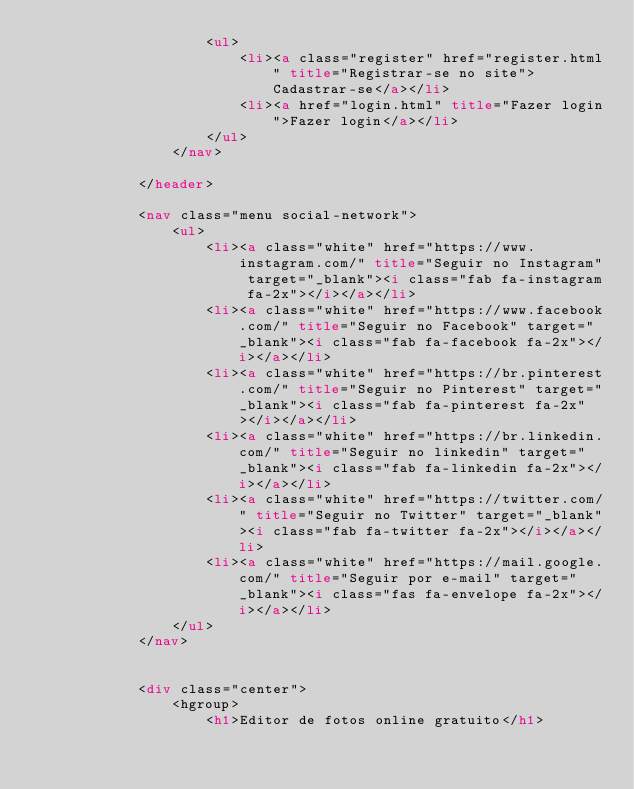<code> <loc_0><loc_0><loc_500><loc_500><_HTML_>                    <ul>
                        <li><a class="register" href="register.html" title="Registrar-se no site">Cadastrar-se</a></li>
                        <li><a href="login.html" title="Fazer login">Fazer login</a></li>
                    </ul>
                </nav>

            </header>

            <nav class="menu social-network">
                <ul>
                    <li><a class="white" href="https://www.instagram.com/" title="Seguir no Instagram" target="_blank"><i class="fab fa-instagram fa-2x"></i></a></li>
                    <li><a class="white" href="https://www.facebook.com/" title="Seguir no Facebook" target="_blank"><i class="fab fa-facebook fa-2x"></i></a></li>
                    <li><a class="white" href="https://br.pinterest.com/" title="Seguir no Pinterest" target="_blank"><i class="fab fa-pinterest fa-2x"></i></a></li>
                    <li><a class="white" href="https://br.linkedin.com/" title="Seguir no linkedin" target="_blank"><i class="fab fa-linkedin fa-2x"></i></a></li>
                    <li><a class="white" href="https://twitter.com/" title="Seguir no Twitter" target="_blank"><i class="fab fa-twitter fa-2x"></i></a></li>
                    <li><a class="white" href="https://mail.google.com/" title="Seguir por e-mail" target="_blank"><i class="fas fa-envelope fa-2x"></i></a></li>
                </ul>
            </nav>


            <div class="center">
                <hgroup>
                    <h1>Editor de fotos online gratuito</h1></code> 